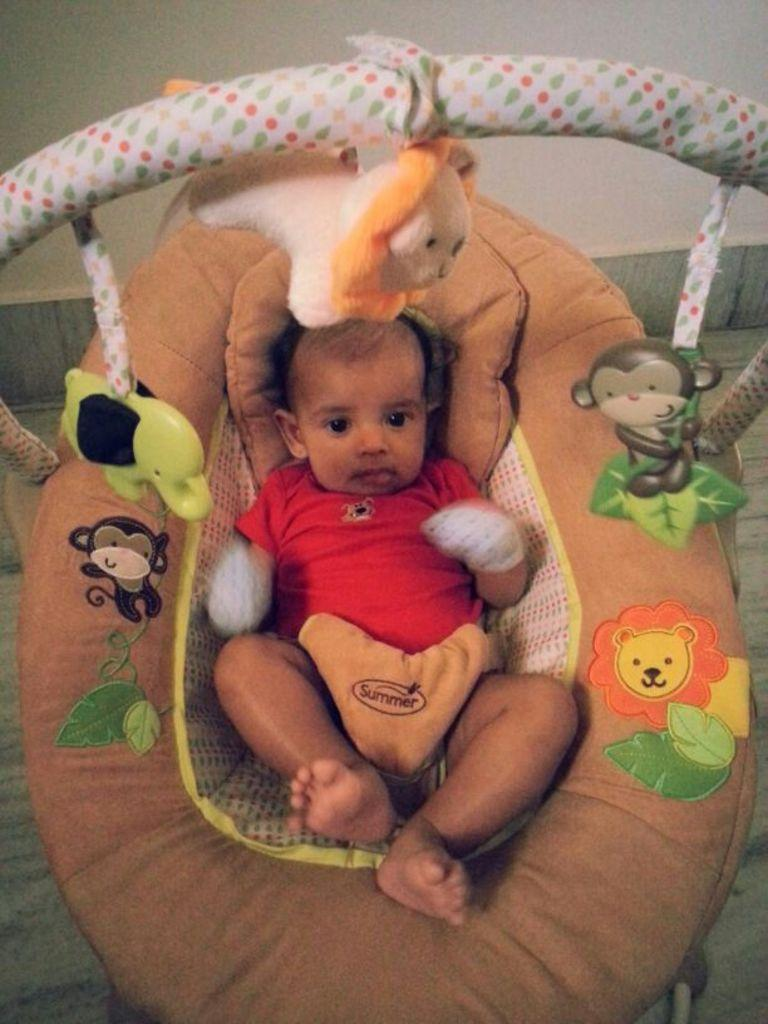What is the main subject of the image? The main subject of the image is a baby. Where is the baby located in the image? The baby is in a baby bed. Are there any additional objects or decorations in the baby bed? Yes, there are dolls attached to the baby bed. What theory can be applied to the cow in the image? There is no cow present in the image, so no theory can be applied to it. 